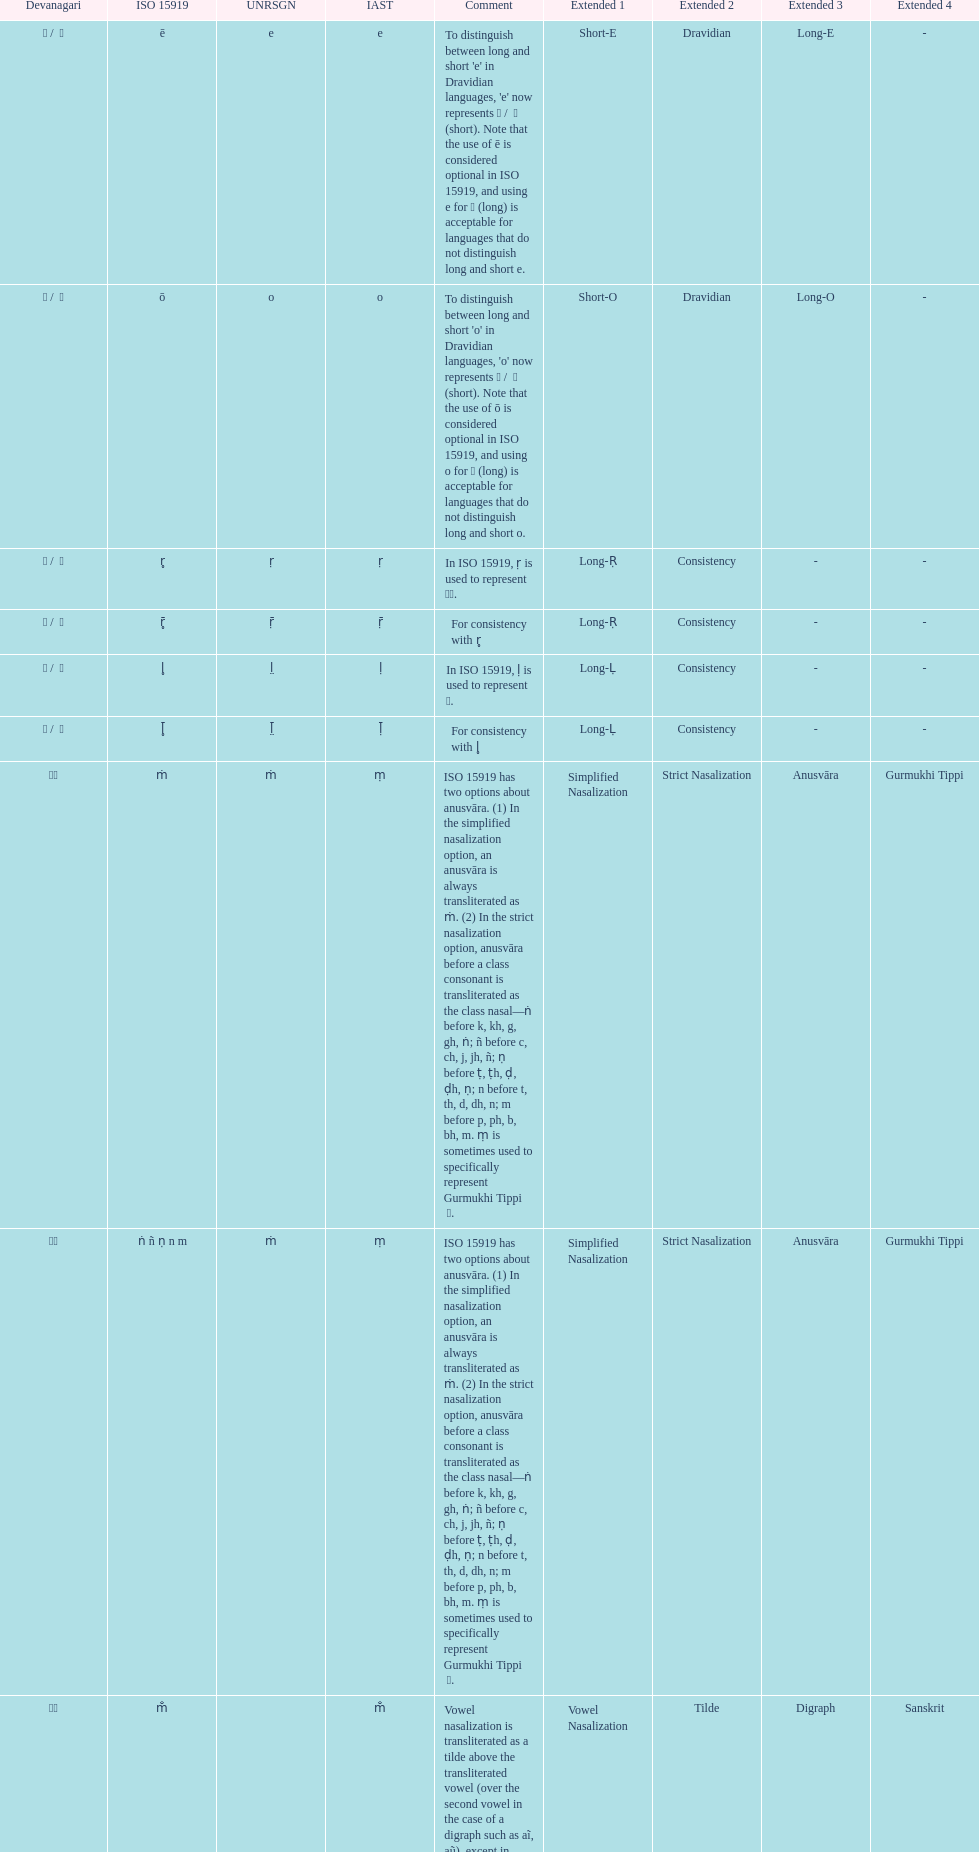What is listed previous to in iso 15919, &#7735; is used to represent &#2355;. under comments? For consistency with r̥. 